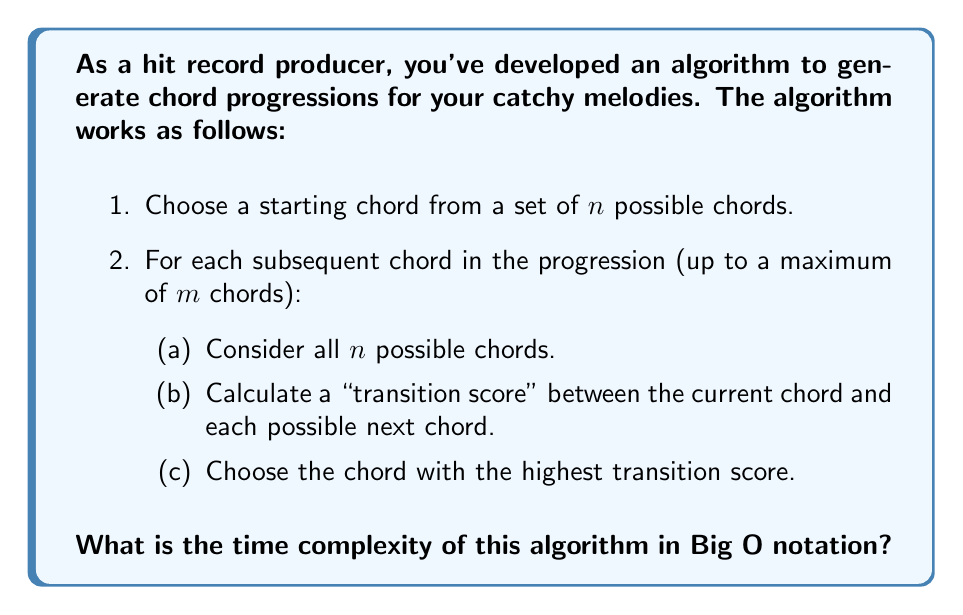Help me with this question. Let's analyze the algorithm step by step:

1. Choosing the starting chord: This is a constant time operation, $O(1)$.

2. For each subsequent chord (up to $m$ chords):
   a. Considering all $n$ possible chords: This is $O(n)$.
   b. Calculating the transition score:
      - For each possible chord, we calculate a score.
      - Assume the calculation of each score is constant time, $O(1)$.
      - We do this $n$ times for each chord.
   c. Choosing the highest score: This requires comparing $n$ scores, which is $O(n)$.

The steps (a), (b), and (c) are performed $n$ times for each chord in the progression.

So, for each chord in the progression, the time complexity is $O(n)$.

We repeat this process for $(m-1)$ chords (excluding the starting chord).

Therefore, the total time complexity is:

$$ O(1) + (m-1) \cdot O(n) = O(mn) $$

The constant term $O(1)$ for choosing the starting chord becomes insignificant as $m$ and $n$ grow, so we can omit it in the final Big O notation.
Answer: $O(mn)$ 